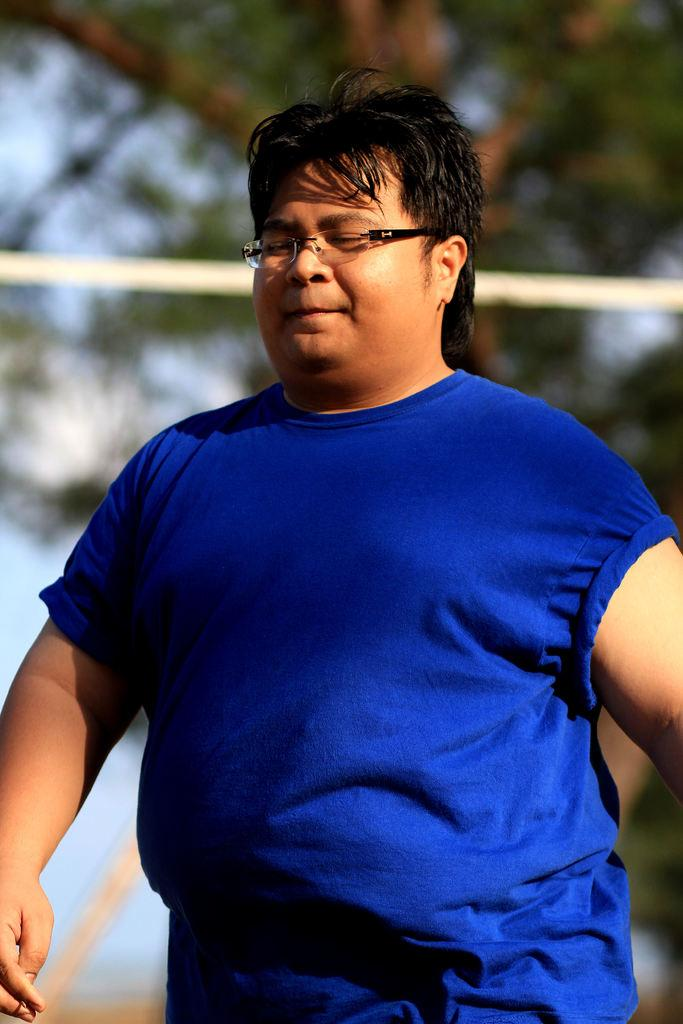Who is present in the image? There is a man in the image. What is the man wearing? The man is wearing a blue shirt. What can be seen in the background of the image? There is a tree and the sky visible in the background of the image. What type of lumber is the man suggesting in the image? There is no indication in the image that the man is suggesting any type of lumber, as the provided facts do not mention lumber or any related context. 